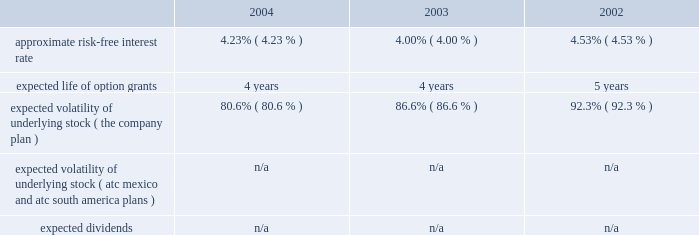American tower corporation and subsidiaries notes to consolidated financial statements 2014 ( continued ) pro forma disclosure 2014the company has adopted the disclosure-only provisions of sfas no .
123 , as amended by sfas no .
148 , and has presented such disclosure in note 1 .
The 201cfair value 201d of each option grant is estimated on the date of grant using the black-scholes option pricing model .
The weighted average fair values of the company 2019s options granted during 2004 , 2003 and 2002 were $ 7.05 , $ 6.32 , and $ 2.23 per share , respectively .
Key assumptions used to apply this pricing model are as follows: .
Voluntary option exchanges 2014in february 2004 , the company issued to eligible employees 1032717 options with an exercise price of $ 11.19 per share , the fair market value of the class a common stock on the date of grant .
These options were issued in connection with a voluntary option exchange program entered into by the company in august 2003 , where the company accepted for surrender and cancelled options ( having an exercise price of $ 10.25 or greater ) to purchase 1831981 shares of its class a common stock .
The program , which was offered to both full and part-time employees , excluding the company 2019s executive officers and its directors , called for the grant ( at least six months and one day from the surrender date to employees still employed on that date ) of new options exercisable for two shares of class a common stock for every three shares of class a common stock issuable upon exercise of a surrendered option .
No options were granted to any employees who participated in the exchange offer between the cancellation date and the new grant date .
In may 2002 , the company issued to eligible employees 2027612 options with an exercise price of $ 3.84 per share , the fair market value of the class a common stock on the date of grant .
These options were issued in connection with a voluntary option exchange program entered into by the company in october 2001 , where the company accepted for surrender and cancelled options to purchase 3471211 shares of its class a common stock .
The program , which was offered to both full and part-time employees , excluding most of the company 2019s executive officers , called for the grant ( at least six months and one day from the surrender date to employees still employed on that date ) of new options exercisable for two shares of class a common stock for every three shares of class a common stock issuable upon exercise of a surrendered option .
No options were granted to any employees who participated in the exchange offer between the cancellation date and the new grant date .
Atc mexico holding stock option plan 2014the company maintains a stock option plan in its atc mexico subsidiary ( atc mexico plan ) .
The atc mexico plan provides for the issuance of options to officers , employees , directors and consultants of atc mexico .
The atc mexico plan limits the number of shares of common stock which may be granted to an aggregate of 360 shares , subject to adjustment based on changes in atc mexico 2019s capital structure .
During 2002 , atc mexico granted options to purchase 318 shares of atc mexico common stock to officers and employees .
Such options were issued at one time with an exercise price of $ 10000 per share .
The exercise price per share was at fair market value as determined by the board of directors with the assistance of an independent appraisal performed at the company 2019s request .
The fair value of atc mexico plan options granted during 2002 were $ 3611 per share as determined by using the black-scholes option pricing model .
As described in note 10 , all outstanding options were exercised in march 2004 .
No options under the atc mexico plan were granted in 2004 or 2003 , or exercised or cancelled in 2003 or 2002 , and no options were exercisable as of december 31 , 2003 or 2002 .
( see note 10. ) .
Based on the black-scholes option pricing model what was the percent of the change in approximate risk-free interest rate from 2003 to 2004? 
Computations: ((4.23 - 4.00) / 4.00)
Answer: 0.0575. 